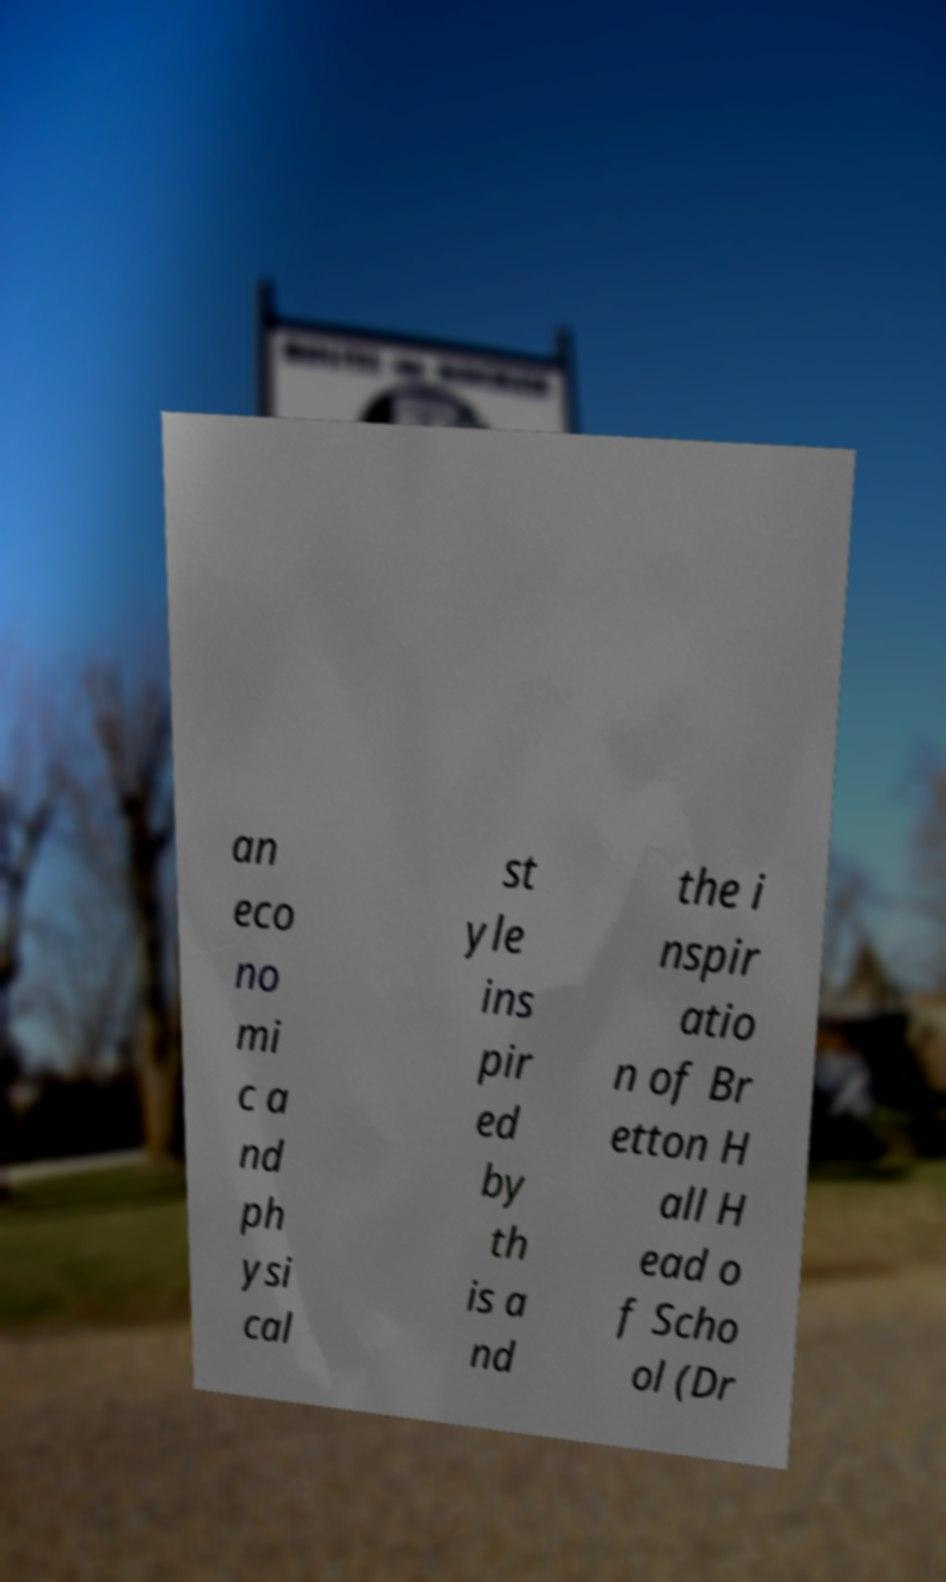There's text embedded in this image that I need extracted. Can you transcribe it verbatim? an eco no mi c a nd ph ysi cal st yle ins pir ed by th is a nd the i nspir atio n of Br etton H all H ead o f Scho ol (Dr 